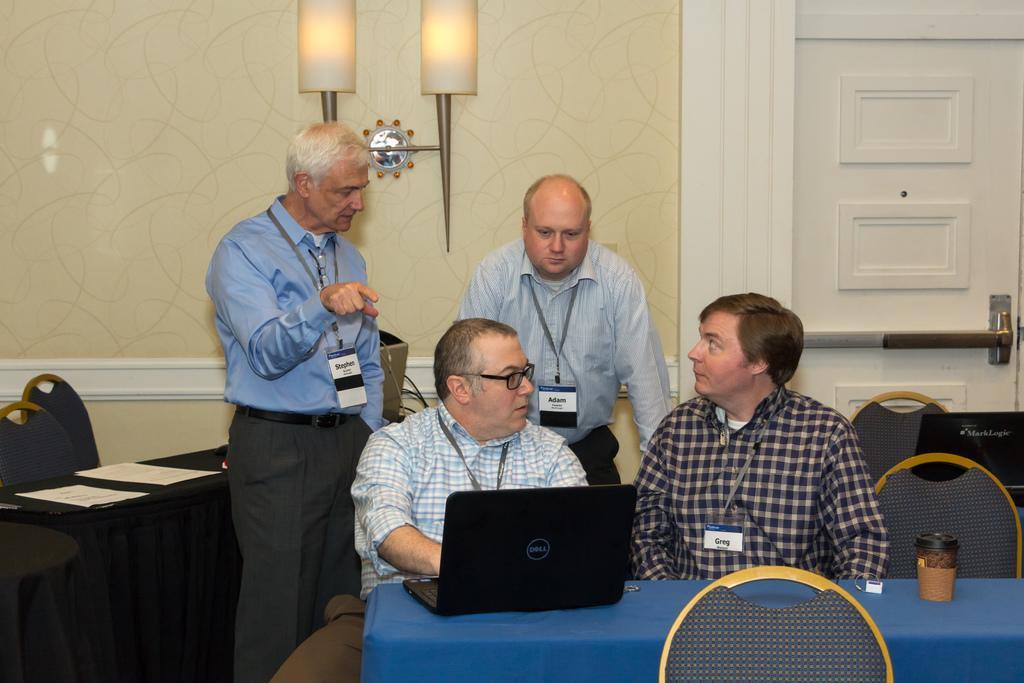In one or two sentences, can you explain what this image depicts? There is room with tables and chairs two men sitting in the chairs talking with each other one of them is operating laptop and other man talking with the two man standing at the back of them. At one corner of the room there is a door for the axis and in front of that on the other table there are some papers placed on it. 